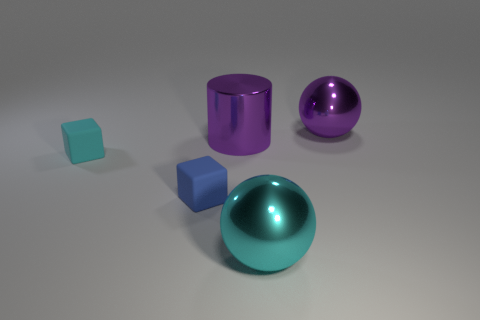Does the large purple cylinder have the same material as the large purple ball? Yes, the large purple cylinder and the large purple ball appear to have the same material finish which is glossy and reflective, indicating that they might be made from similar substances such as polished metal or plastic with a similar paint coating. 